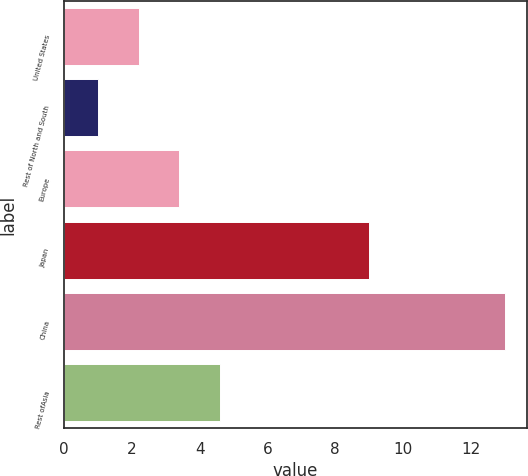<chart> <loc_0><loc_0><loc_500><loc_500><bar_chart><fcel>United States<fcel>Rest of North and South<fcel>Europe<fcel>Japan<fcel>China<fcel>Rest ofAsia<nl><fcel>2.2<fcel>1<fcel>3.4<fcel>9<fcel>13<fcel>4.6<nl></chart> 